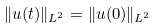<formula> <loc_0><loc_0><loc_500><loc_500>\| u ( t ) \| _ { L ^ { 2 } } = \| u ( 0 ) \| _ { L ^ { 2 } }</formula> 